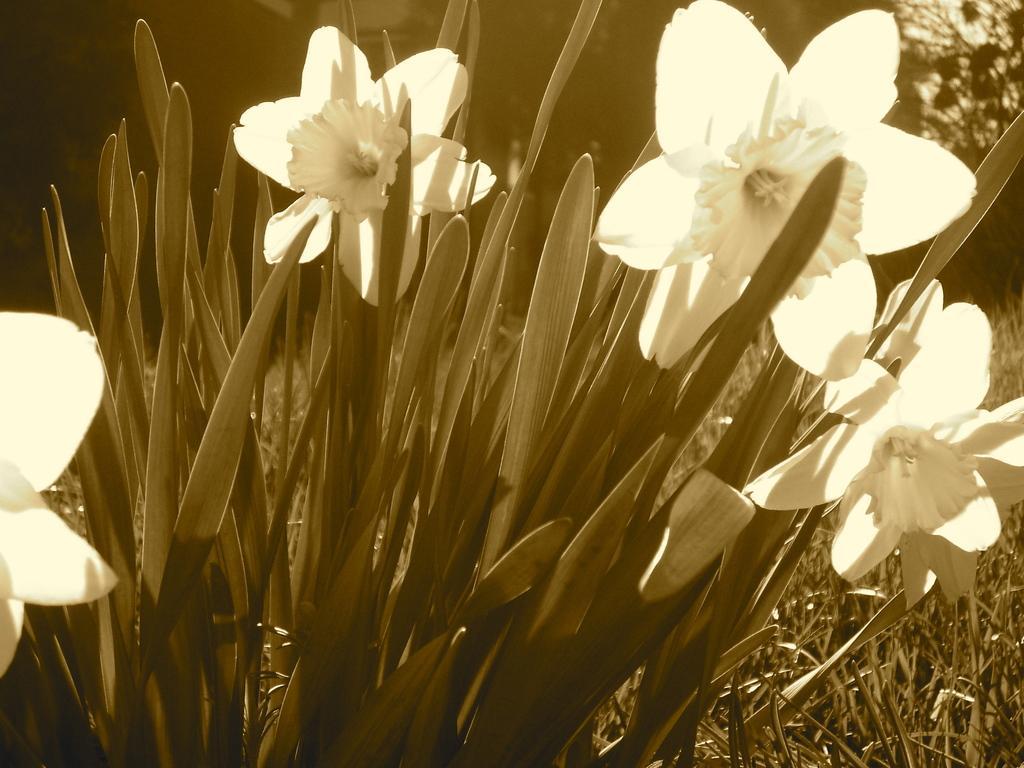How would you summarize this image in a sentence or two? Here we can see a plant with flowers and in the background the image is not clear but we can see a tree on the right side. 